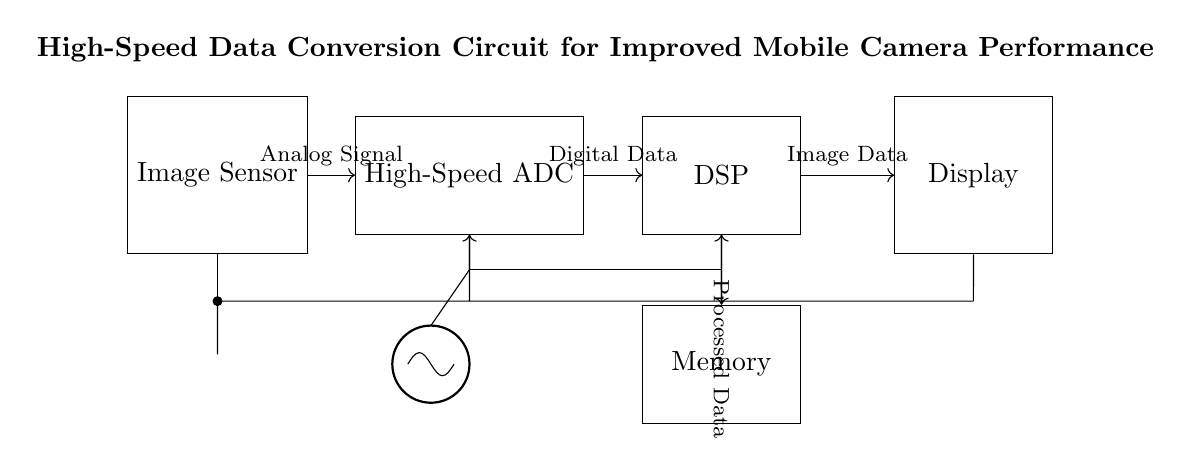What is the main component that receives the analog signal? The main component that receives the analog signal is the image sensor, as it is the first component depicted in the circuit diagram and is directly connected to the high-speed ADC.
Answer: Image Sensor What type of data does the ADC output? The ADC outputs digital data, as indicated by the label on the connection between the ADC and the DSP. This conversion from an analog signal to digital data is crucial for further processing.
Answer: Digital Data How many components are directly connected to the DSP? The DSP is directly connected to two components: the ADC, which provides digital data, and the memory, which will store the processed data. This shows the DSP is a critical processing unit in the circuit.
Answer: Two What is the function of the memory in this circuit? The function of the memory in the circuit is to store processed data coming from the DSP, which is essential for retaining information for display or further processing in the mobile device.
Answer: Store Processed Data Which component provides the clock signal to the system? The clock signal is provided by the oscillator component, which is shown connected to the ADC and DSP, ensuring synchronized operation of these components for accurate data processing.
Answer: Clock What type of signal is sent from the DSP to the display? The signal sent from the DSP to the display is processed data. This indicates that the display receives images or information that have been processed by the DSP for visualization.
Answer: Image Data What is the role of the power supply in this circuit? The power supply provides the necessary voltage to all components in the circuit, ensuring they operate correctly. It connects to each component, thereby maintaining a consistent power requirement for optimal function.
Answer: Provide Voltage 